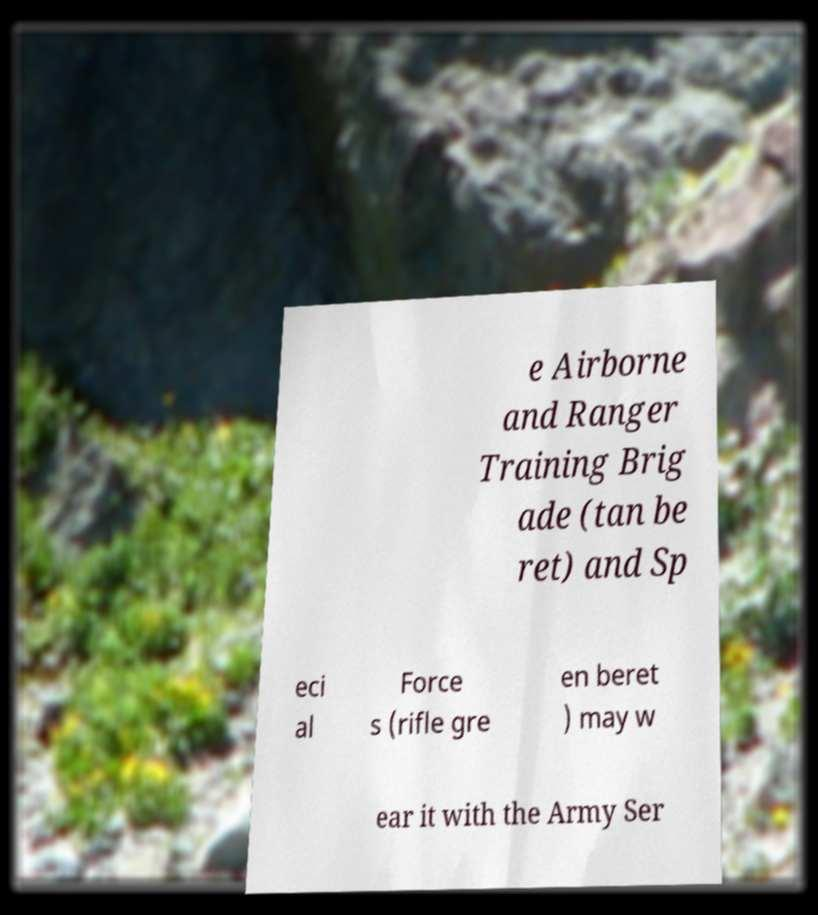I need the written content from this picture converted into text. Can you do that? e Airborne and Ranger Training Brig ade (tan be ret) and Sp eci al Force s (rifle gre en beret ) may w ear it with the Army Ser 